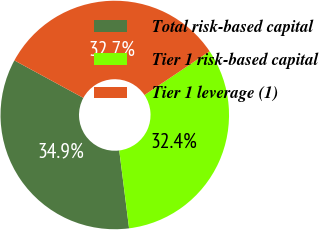Convert chart. <chart><loc_0><loc_0><loc_500><loc_500><pie_chart><fcel>Total risk-based capital<fcel>Tier 1 risk-based capital<fcel>Tier 1 leverage (1)<nl><fcel>34.92%<fcel>32.41%<fcel>32.66%<nl></chart> 